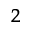Convert formula to latex. <formula><loc_0><loc_0><loc_500><loc_500>^ { 2 }</formula> 